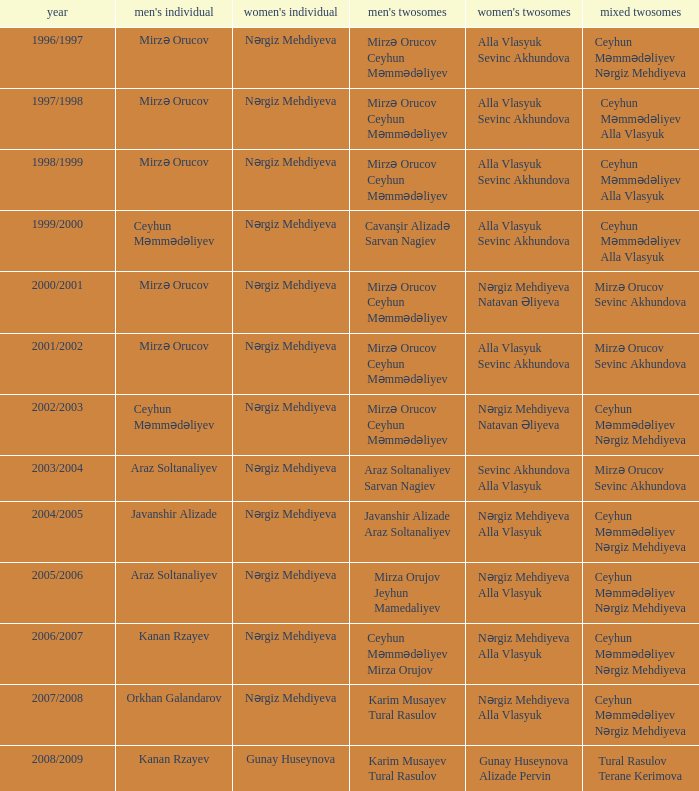Who were all womens doubles for the year 2000/2001? Nərgiz Mehdiyeva Natavan Əliyeva. 